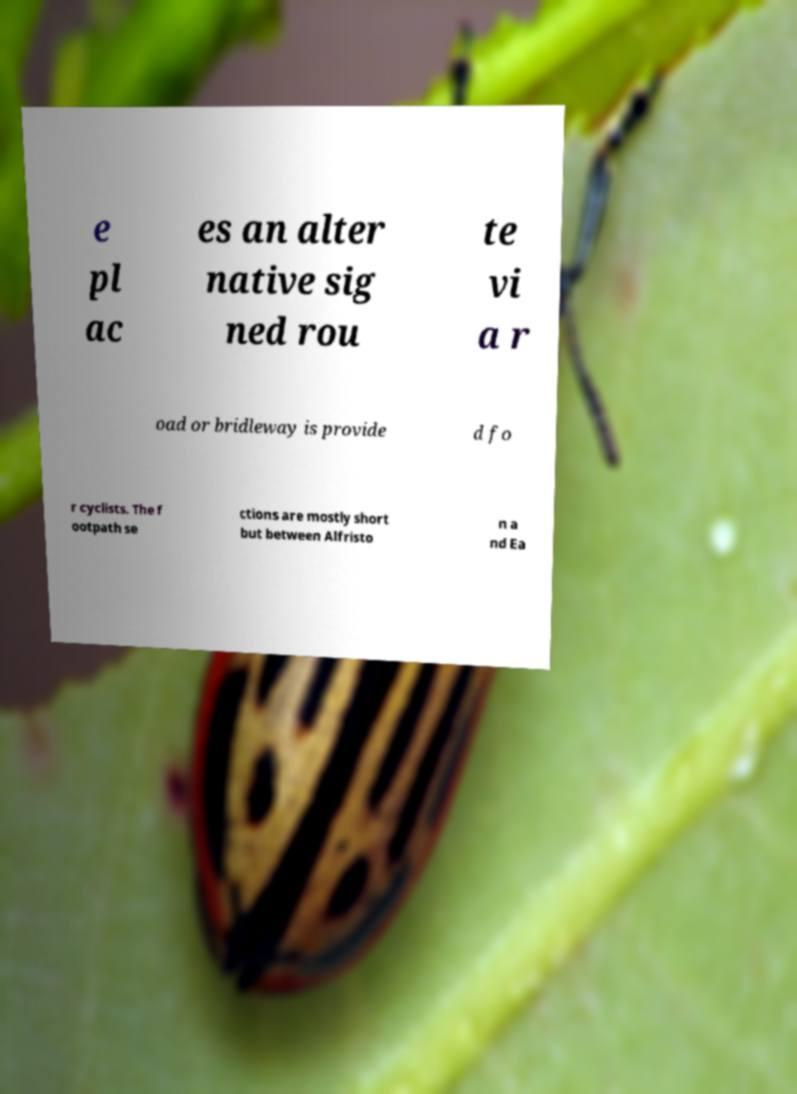I need the written content from this picture converted into text. Can you do that? e pl ac es an alter native sig ned rou te vi a r oad or bridleway is provide d fo r cyclists. The f ootpath se ctions are mostly short but between Alfristo n a nd Ea 